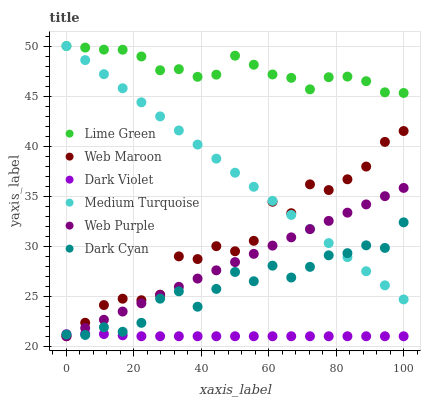Does Dark Violet have the minimum area under the curve?
Answer yes or no. Yes. Does Lime Green have the maximum area under the curve?
Answer yes or no. Yes. Does Web Purple have the minimum area under the curve?
Answer yes or no. No. Does Web Purple have the maximum area under the curve?
Answer yes or no. No. Is Web Purple the smoothest?
Answer yes or no. Yes. Is Web Maroon the roughest?
Answer yes or no. Yes. Is Dark Violet the smoothest?
Answer yes or no. No. Is Dark Violet the roughest?
Answer yes or no. No. Does Web Maroon have the lowest value?
Answer yes or no. Yes. Does Medium Turquoise have the lowest value?
Answer yes or no. No. Does Lime Green have the highest value?
Answer yes or no. Yes. Does Web Purple have the highest value?
Answer yes or no. No. Is Web Purple less than Lime Green?
Answer yes or no. Yes. Is Lime Green greater than Web Purple?
Answer yes or no. Yes. Does Web Purple intersect Dark Violet?
Answer yes or no. Yes. Is Web Purple less than Dark Violet?
Answer yes or no. No. Is Web Purple greater than Dark Violet?
Answer yes or no. No. Does Web Purple intersect Lime Green?
Answer yes or no. No. 